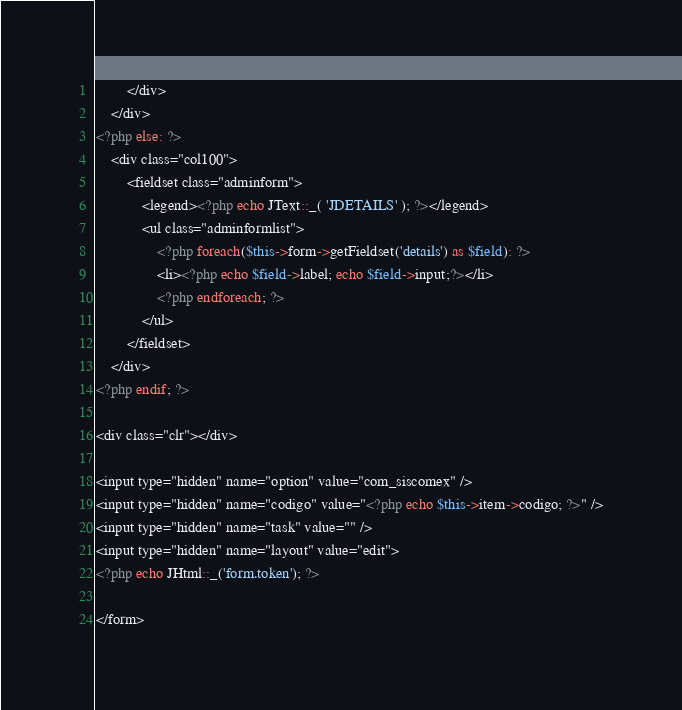<code> <loc_0><loc_0><loc_500><loc_500><_PHP_>		</div>
	</div>
<?php else: ?>
	<div class="col100">
		<fieldset class="adminform">
			<legend><?php echo JText::_( 'JDETAILS' ); ?></legend>
			<ul class="adminformlist">
				<?php foreach($this->form->getFieldset('details') as $field): ?>
				<li><?php echo $field->label; echo $field->input;?></li>
				<?php endforeach; ?>
			</ul>
		</fieldset>
	</div>
<?php endif; ?>

<div class="clr"></div>

<input type="hidden" name="option" value="com_siscomex" />
<input type="hidden" name="codigo" value="<?php echo $this->item->codigo; ?>" />
<input type="hidden" name="task" value="" />
<input type="hidden" name="layout" value="edit">
<?php echo JHtml::_('form.token'); ?>

</form>
</code> 